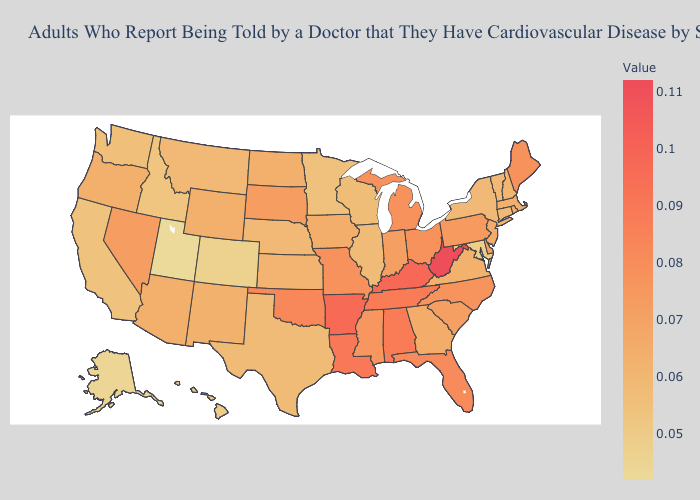Among the states that border Minnesota , which have the highest value?
Answer briefly. South Dakota. Which states have the lowest value in the West?
Quick response, please. Utah. Does Utah have the lowest value in the West?
Give a very brief answer. Yes. Which states have the lowest value in the MidWest?
Be succinct. Minnesota. Does Michigan have a higher value than New Mexico?
Keep it brief. Yes. 